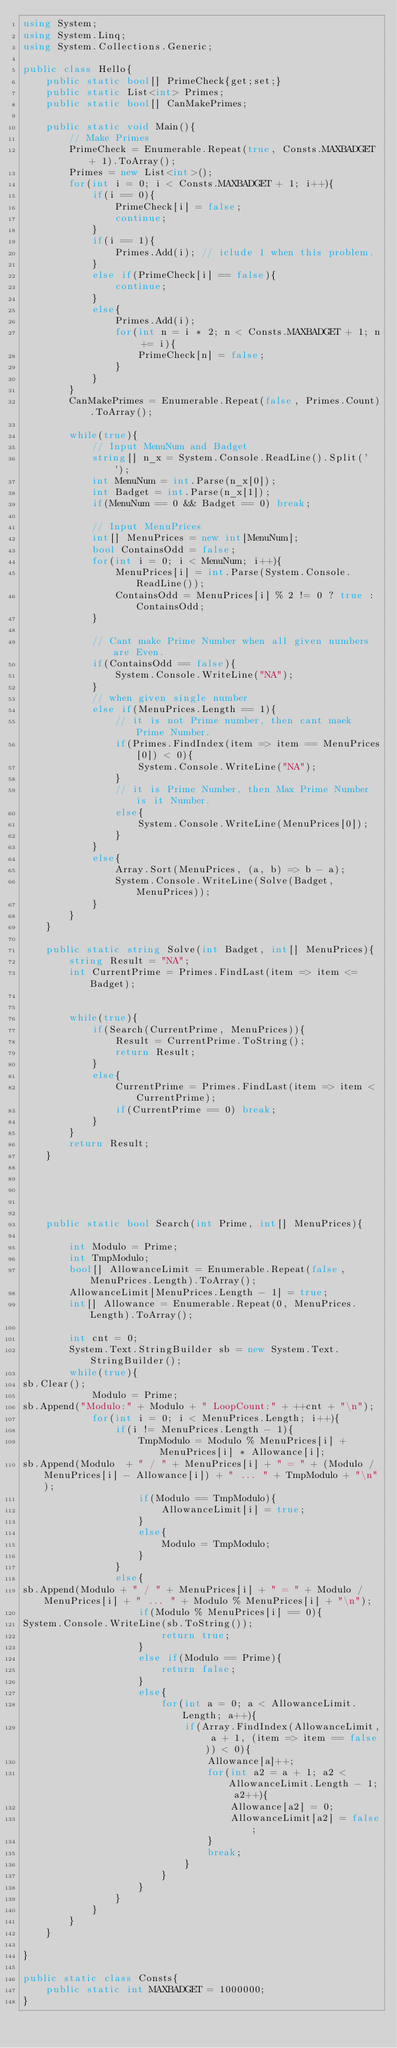<code> <loc_0><loc_0><loc_500><loc_500><_C#_>using System;
using System.Linq;
using System.Collections.Generic;

public class Hello{
    public static bool[] PrimeCheck{get;set;}
    public static List<int> Primes;
    public static bool[] CanMakePrimes;
    
    public static void Main(){
        // Make Primes
        PrimeCheck = Enumerable.Repeat(true, Consts.MAXBADGET + 1).ToArray();
        Primes = new List<int>();
        for(int i = 0; i < Consts.MAXBADGET + 1; i++){
            if(i == 0){
                PrimeCheck[i] = false;
                continue;
            }
            if(i == 1){
                Primes.Add(i); // iclude 1 when this problem.
            }
            else if(PrimeCheck[i] == false){
                continue;
            }
            else{
                Primes.Add(i);
                for(int n = i * 2; n < Consts.MAXBADGET + 1; n += i){
                    PrimeCheck[n] = false;
                }
            }
        }
        CanMakePrimes = Enumerable.Repeat(false, Primes.Count).ToArray();

        while(true){
            // Input MenuNum and Badget
            string[] n_x = System.Console.ReadLine().Split(' ');
            int MenuNum = int.Parse(n_x[0]);
            int Badget = int.Parse(n_x[1]);
            if(MenuNum == 0 && Badget == 0) break;
            
            // Input MenuPrices
            int[] MenuPrices = new int[MenuNum];
            bool ContainsOdd = false;
            for(int i = 0; i < MenuNum; i++){
                MenuPrices[i] = int.Parse(System.Console.ReadLine());
                ContainsOdd = MenuPrices[i] % 2 != 0 ? true : ContainsOdd;
            }
              
            // Cant make Prime Number when all given numbers are Even.
            if(ContainsOdd == false){ 
                System.Console.WriteLine("NA");
            }
            // when given single number
            else if(MenuPrices.Length == 1){
                // it is not Prime number, then cant maek Prime Number.
                if(Primes.FindIndex(item => item == MenuPrices[0]) < 0){
                    System.Console.WriteLine("NA");
                }
                // it is Prime Number, then Max Prime Number is it Number.
                else{
                    System.Console.WriteLine(MenuPrices[0]);
                }
            }            
            else{
                Array.Sort(MenuPrices, (a, b) => b - a);
                System.Console.WriteLine(Solve(Badget, MenuPrices));
            }
        }
    }
    
    public static string Solve(int Badget, int[] MenuPrices){
        string Result = "NA";
        int CurrentPrime = Primes.FindLast(item => item <= Badget);
        

        while(true){
            if(Search(CurrentPrime, MenuPrices)){
                Result = CurrentPrime.ToString();
                return Result;
            }
            else{
                CurrentPrime = Primes.FindLast(item => item < CurrentPrime);
                if(CurrentPrime == 0) break;
            }
        }
        return Result;
    }

    
    
    
    
    public static bool Search(int Prime, int[] MenuPrices){

        int Modulo = Prime;
        int TmpModulo;
        bool[] AllowanceLimit = Enumerable.Repeat(false, MenuPrices.Length).ToArray();
        AllowanceLimit[MenuPrices.Length - 1] = true;
        int[] Allowance = Enumerable.Repeat(0, MenuPrices.Length).ToArray();
        
        int cnt = 0;
        System.Text.StringBuilder sb = new System.Text.StringBuilder();
        while(true){
sb.Clear();
            Modulo = Prime;
sb.Append("Modulo:" + Modulo + " LoopCount:" + ++cnt + "\n");
            for(int i = 0; i < MenuPrices.Length; i++){
                if(i != MenuPrices.Length - 1){
                    TmpModulo = Modulo % MenuPrices[i] + MenuPrices[i] * Allowance[i];
sb.Append(Modulo  + " / " + MenuPrices[i] + " = " + (Modulo / MenuPrices[i] - Allowance[i]) + " ... " + TmpModulo + "\n");
                    if(Modulo == TmpModulo){
                        AllowanceLimit[i] = true;
                    }
                    else{
                        Modulo = TmpModulo;
                    }
                }
                else{
sb.Append(Modulo + " / " + MenuPrices[i] + " = " + Modulo / MenuPrices[i] + " ... " + Modulo % MenuPrices[i] + "\n");
                    if(Modulo % MenuPrices[i] == 0){
System.Console.WriteLine(sb.ToString());
                        return true;
                    }
                    else if(Modulo == Prime){
                        return false;
                    }
                    else{
                        for(int a = 0; a < AllowanceLimit.Length; a++){
                            if(Array.FindIndex(AllowanceLimit, a + 1, (item => item == false)) < 0){
                                Allowance[a]++;
                                for(int a2 = a + 1; a2 < AllowanceLimit.Length - 1; a2++){
                                    Allowance[a2] = 0;
                                    AllowanceLimit[a2] = false;
                                }
                                break;
                            }
                        }
                    }
                }
            }
        }
    }

}

public static class Consts{
    public static int MAXBADGET = 1000000;
}</code> 